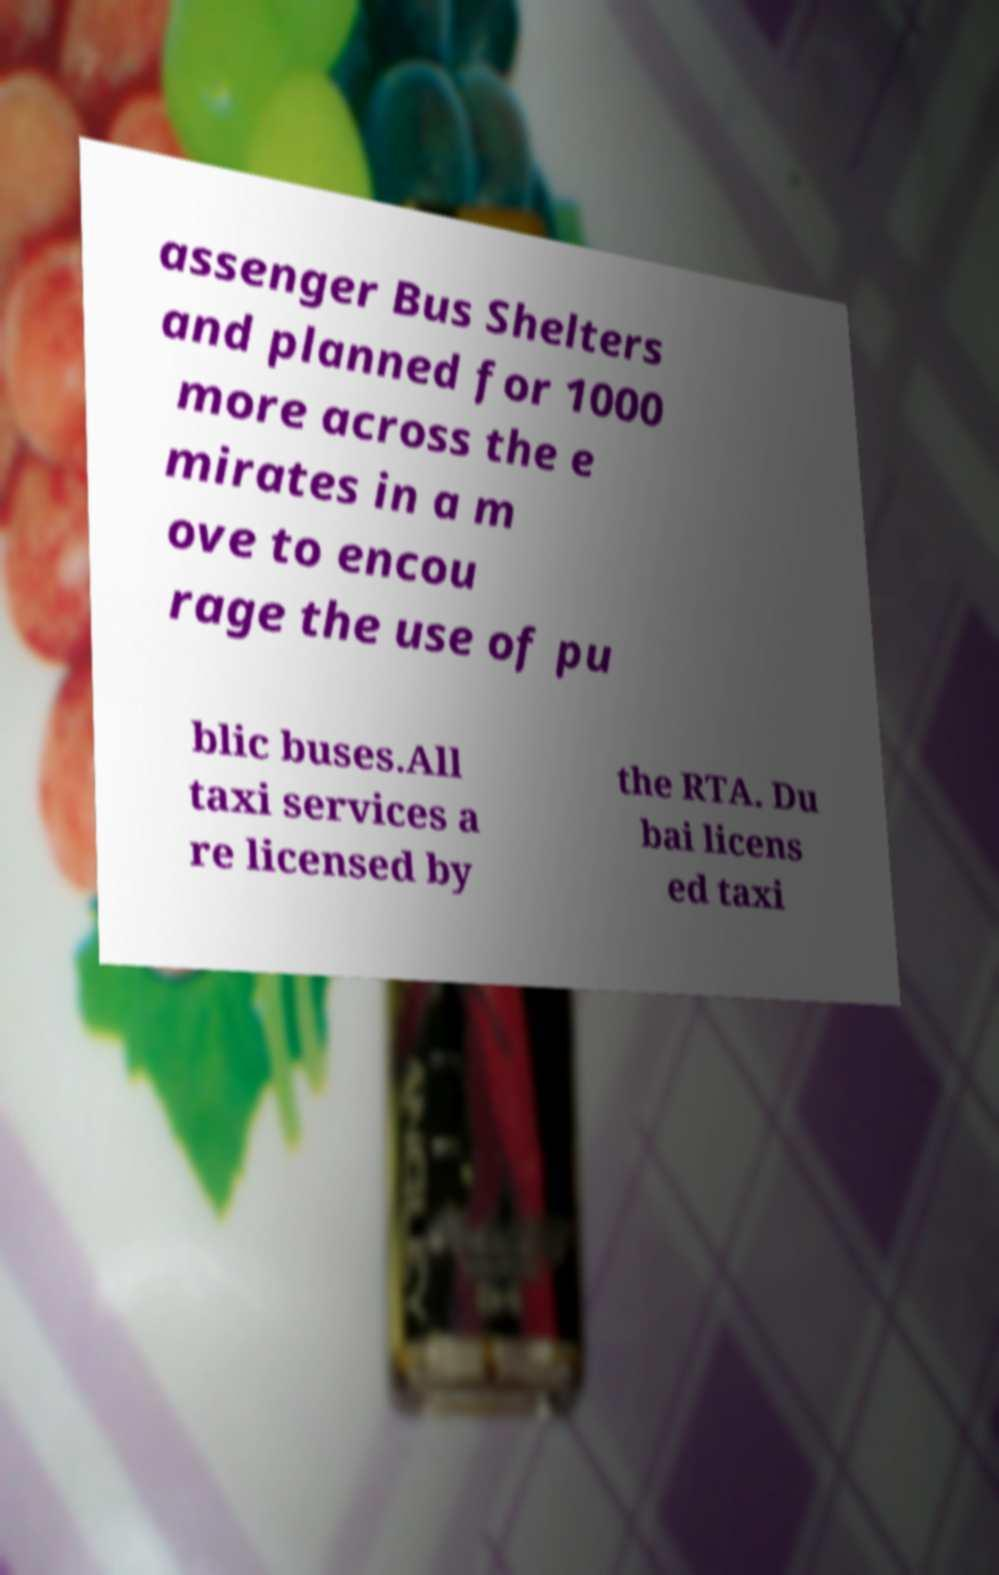I need the written content from this picture converted into text. Can you do that? assenger Bus Shelters and planned for 1000 more across the e mirates in a m ove to encou rage the use of pu blic buses.All taxi services a re licensed by the RTA. Du bai licens ed taxi 